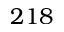Convert formula to latex. <formula><loc_0><loc_0><loc_500><loc_500>2 1 8</formula> 